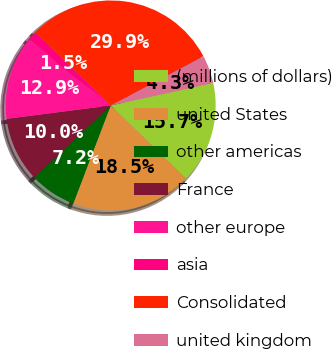Convert chart to OTSL. <chart><loc_0><loc_0><loc_500><loc_500><pie_chart><fcel>(millions of dollars)<fcel>united States<fcel>other americas<fcel>France<fcel>other europe<fcel>asia<fcel>Consolidated<fcel>united kingdom<nl><fcel>15.7%<fcel>18.55%<fcel>7.16%<fcel>10.01%<fcel>12.86%<fcel>1.47%<fcel>29.93%<fcel>4.32%<nl></chart> 